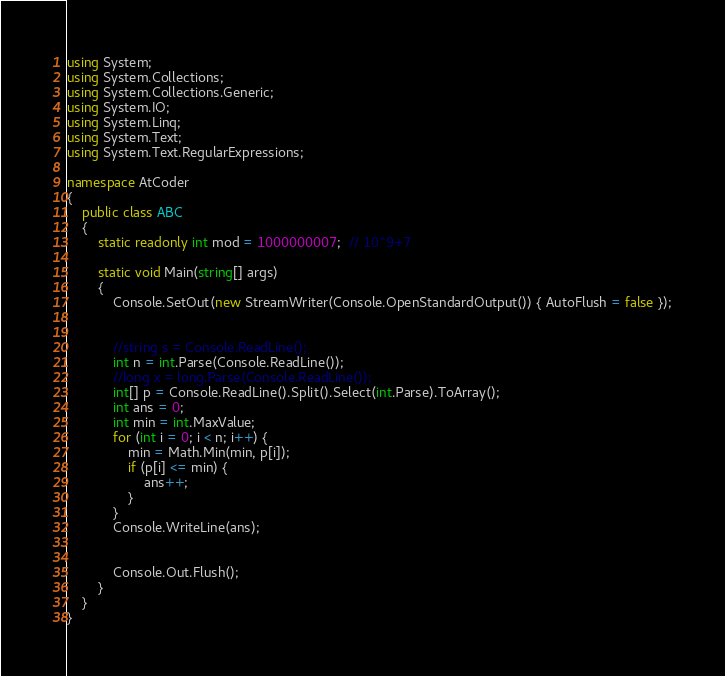<code> <loc_0><loc_0><loc_500><loc_500><_C#_>using System;
using System.Collections;
using System.Collections.Generic;
using System.IO;
using System.Linq;
using System.Text;
using System.Text.RegularExpressions;

namespace AtCoder
{
	public class ABC
	{
		static readonly int mod = 1000000007;  // 10^9+7

		static void Main(string[] args)
		{
			Console.SetOut(new StreamWriter(Console.OpenStandardOutput()) { AutoFlush = false });


			//string s = Console.ReadLine();
			int n = int.Parse(Console.ReadLine());
			//long x = long.Parse(Console.ReadLine());
			int[] p = Console.ReadLine().Split().Select(int.Parse).ToArray();
			int ans = 0;
			int min = int.MaxValue;
			for (int i = 0; i < n; i++) {
				min = Math.Min(min, p[i]);
				if (p[i] <= min) {
					ans++;
				}
			}
			Console.WriteLine(ans);


			Console.Out.Flush();
		}
	}
}
</code> 